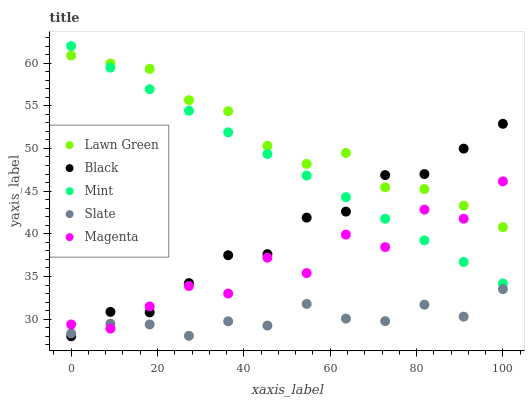Does Slate have the minimum area under the curve?
Answer yes or no. Yes. Does Lawn Green have the maximum area under the curve?
Answer yes or no. Yes. Does Black have the minimum area under the curve?
Answer yes or no. No. Does Black have the maximum area under the curve?
Answer yes or no. No. Is Mint the smoothest?
Answer yes or no. Yes. Is Magenta the roughest?
Answer yes or no. Yes. Is Slate the smoothest?
Answer yes or no. No. Is Slate the roughest?
Answer yes or no. No. Does Black have the lowest value?
Answer yes or no. Yes. Does Slate have the lowest value?
Answer yes or no. No. Does Mint have the highest value?
Answer yes or no. Yes. Does Black have the highest value?
Answer yes or no. No. Is Slate less than Mint?
Answer yes or no. Yes. Is Mint greater than Slate?
Answer yes or no. Yes. Does Magenta intersect Slate?
Answer yes or no. Yes. Is Magenta less than Slate?
Answer yes or no. No. Is Magenta greater than Slate?
Answer yes or no. No. Does Slate intersect Mint?
Answer yes or no. No. 